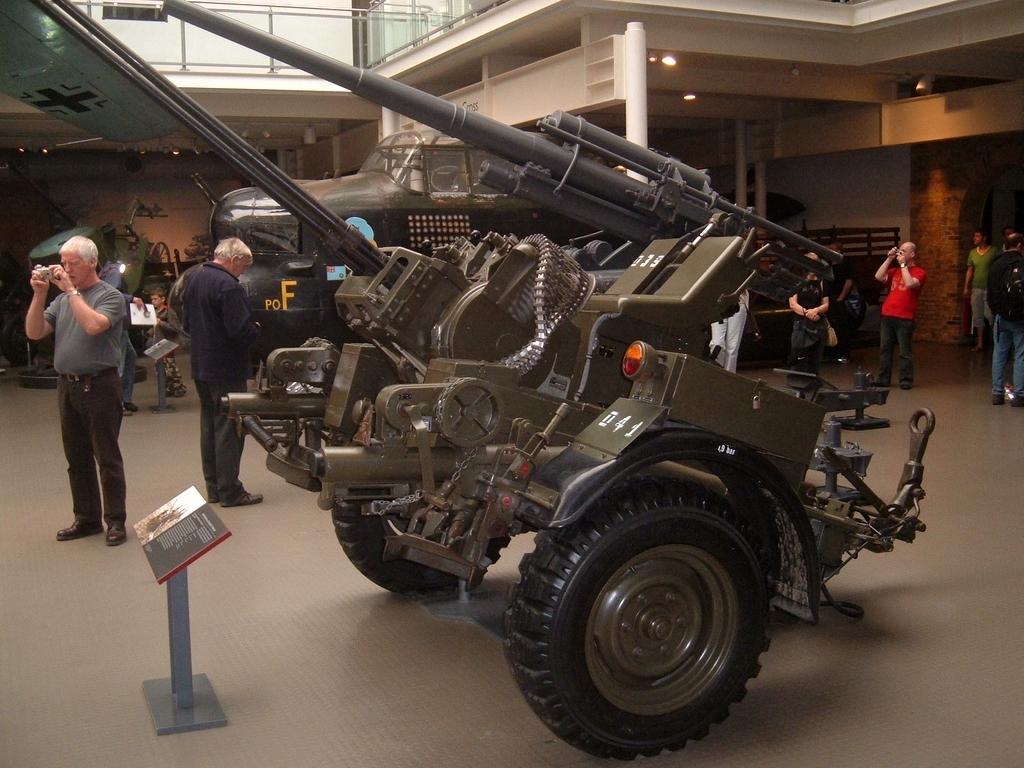Describe this image in one or two sentences. As we can see in the image there is a vehicle, few people here and there, wall, fence and the person on the left side is holding a camera. In the front there is a book. 